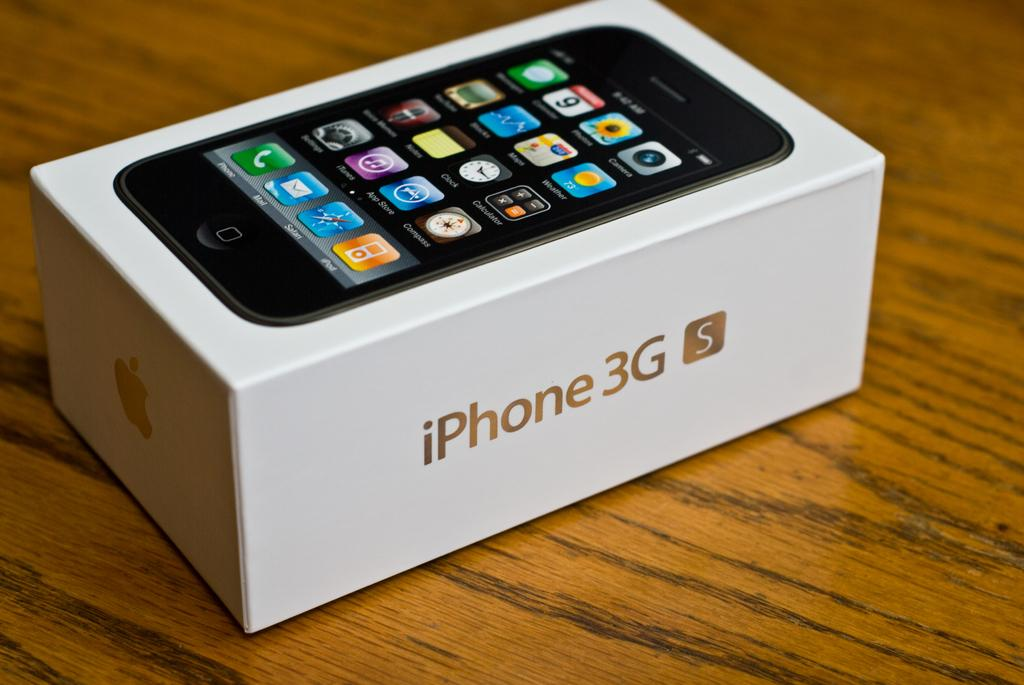Provide a one-sentence caption for the provided image. A box of iPhone 3G S placed on a table. 